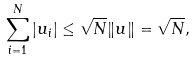Convert formula to latex. <formula><loc_0><loc_0><loc_500><loc_500>\sum _ { i = 1 } ^ { N } | u _ { i } | \leq \sqrt { N } \| u \| = \sqrt { N } ,</formula> 